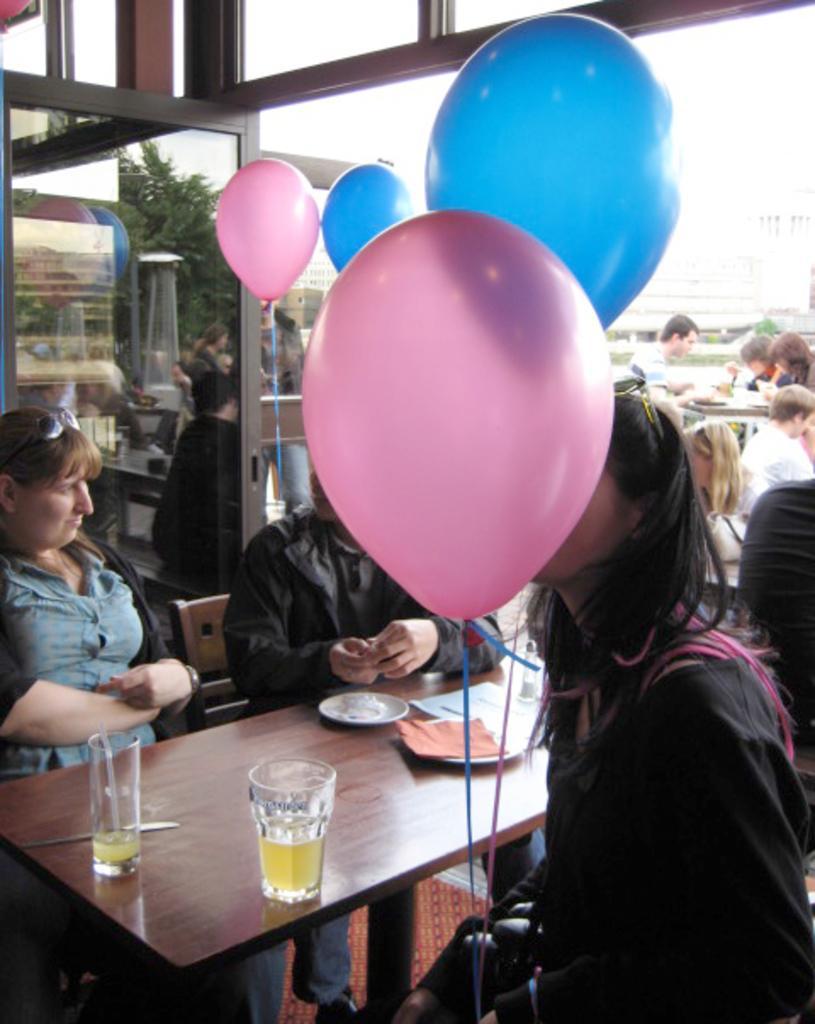Please provide a concise description of this image. These persons are sitting on the chairs and this person holding balloons. We can see glass,knife,plate on the table. On the background we can see glass window,from this glass window we can see persons,table,trees. 